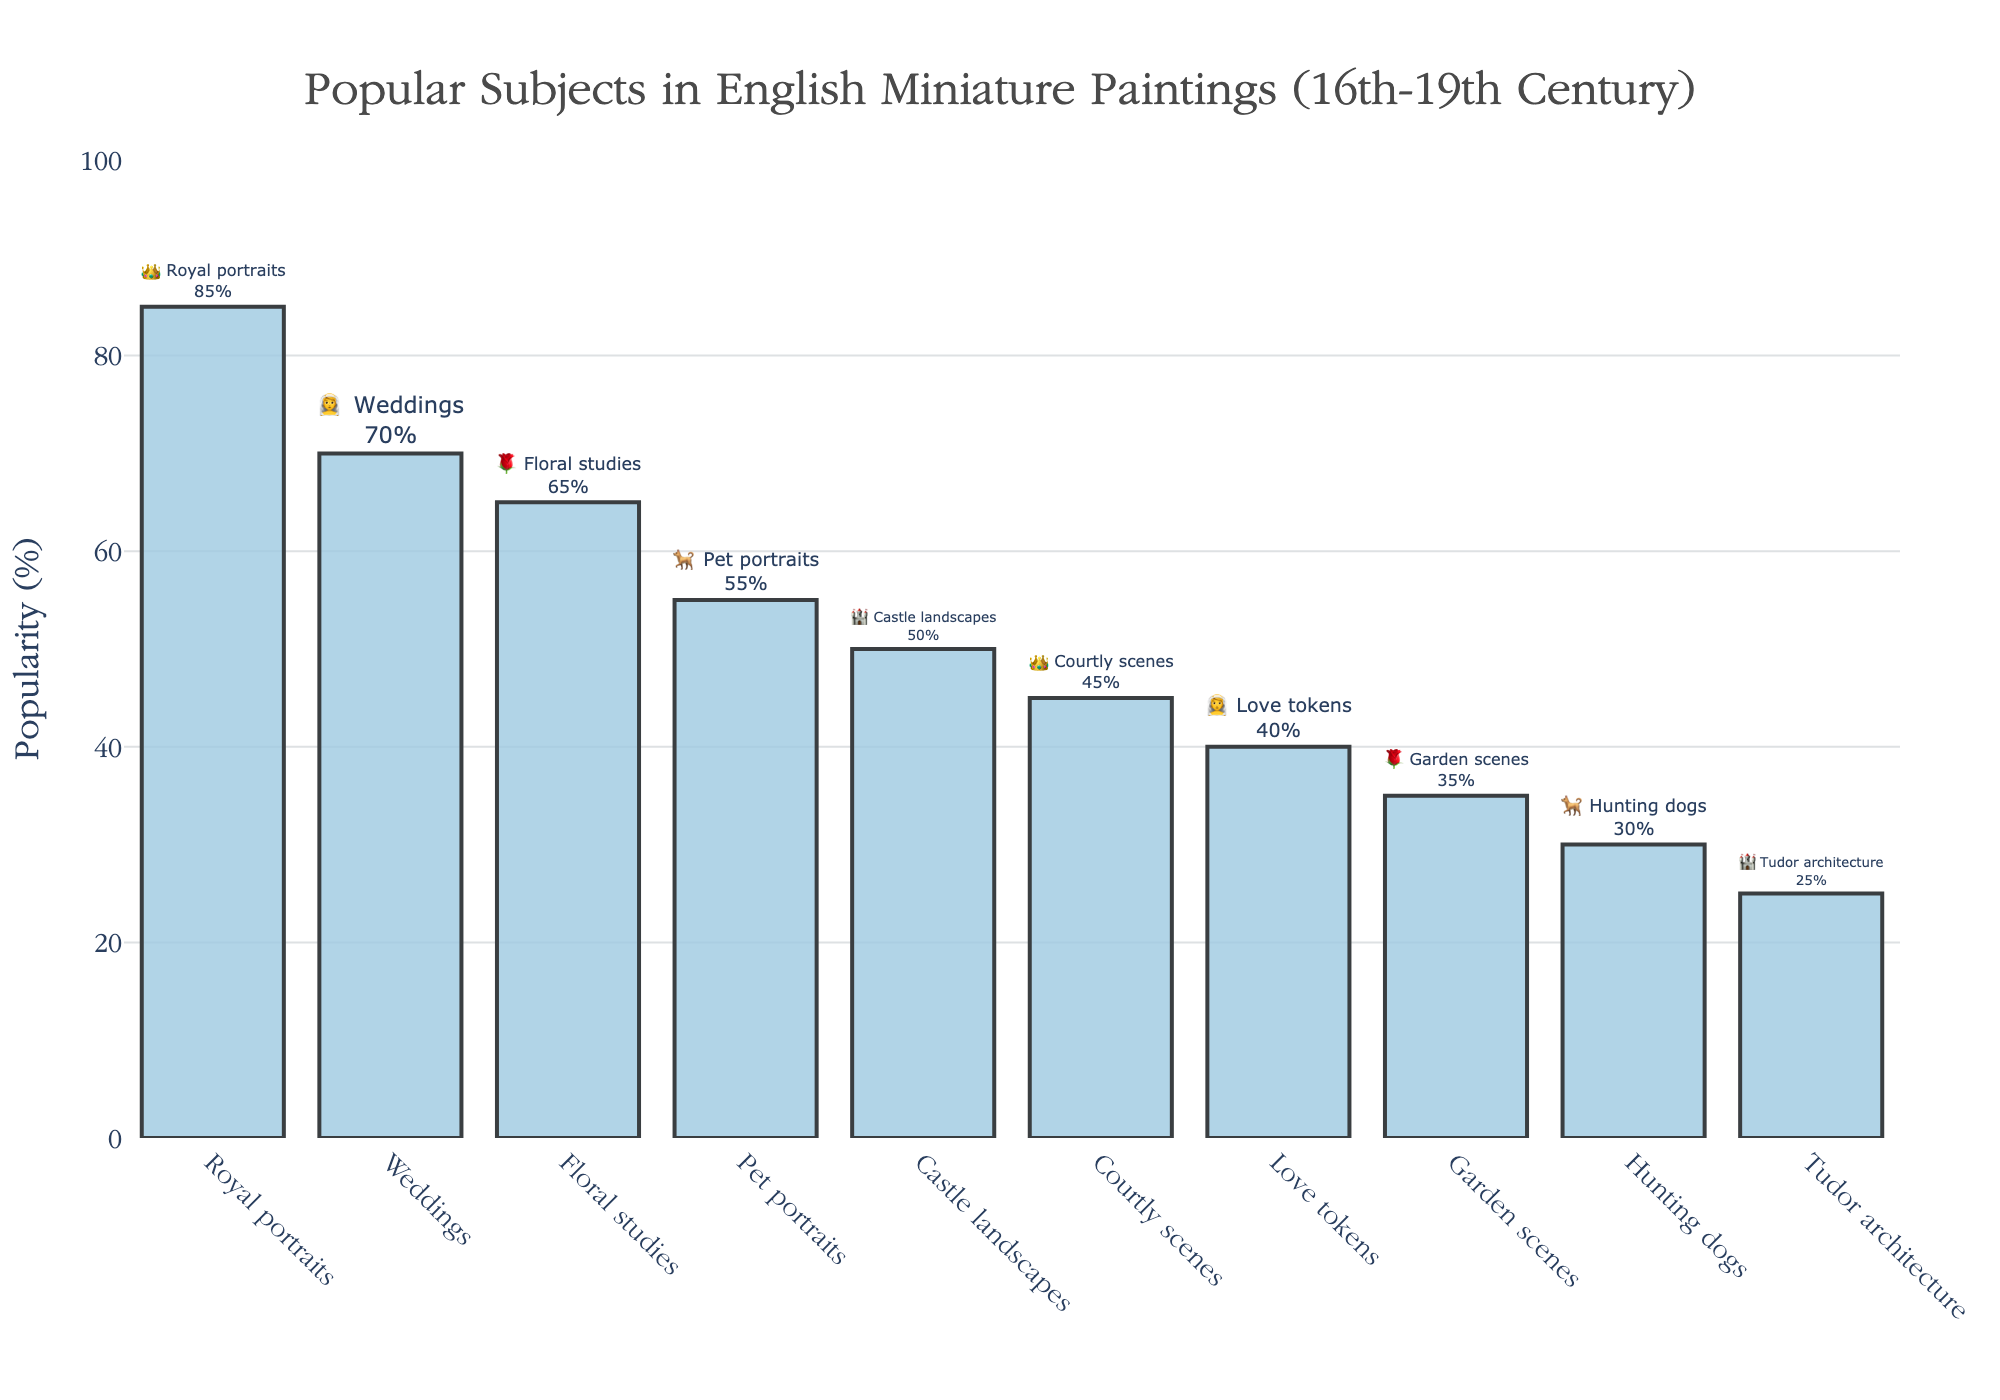What is the title of the figure? The title is usually found at the top of the figure and it provides a quick summary of what the figure represents. In this case, it is "Popular Subjects in English Miniature Paintings (16th-19th Century)"
Answer: Popular Subjects in English Miniature Paintings (16th-19th Century) Which subject has the highest popularity? The bar that reaches the highest point on the Y-axis indicates the most popular subject. Here, the bar labeled "Royal portraits" is the tallest.
Answer: Royal portraits (👑) How much more popular are Royal portraits compared to Tudor architecture? Subtract the popularity percentage of Tudor architecture from that of Royal portraits. Royal portraits have 85% popularity and Tudor architecture has 25%. 85 - 25 = 60
Answer: 60% What are the two least popular subjects, and their popularity percentages? To determine the least popular subjects, look for the bars that are shortest on the Y-axis. These bars are for "Tudor architecture" and "Hunting dogs". Their popularity percentages are 25% and 30% respectively.
Answer: Tudor architecture (25%), Hunting dogs (30%) What is the average popularity percentage of all the subjects? To compute the average, sum all the popularity percentages and divide by the number of subjects. (85 + 70 + 65 + 55 + 50 + 45 + 40 + 35 + 30 + 25) / 10 = 50
Answer: 50% Which emoji represents floral studies and what is its popularity? The figure includes emojis associated with each subject. Find the emoji next to "Floral studies" and its corresponding Y-axis value. The emoji is 🌹 and the popularity is 65%.
Answer: 🌹, 65% Is the popularity of Pet portraits greater or less than that of Weddings? Compare the height of the bars corresponding to Pet portraits and Weddings. Pet portraits have a popularity of 55%, while Weddings have 70%. Therefore, Pet portraits are less popular than Weddings.
Answer: Less How many subjects have a popularity greater than 50%? Count the number of bars that extend above the 50% mark on the Y-axis. Five subjects exceed 50%: "Royal portraits", "Weddings", "Floral studies", "Pet portraits", and "Castle landscapes".
Answer: 5 subjects What is the difference in popularity between Castle landscapes and Courtly scenes? Find the popularity percentage of both subjects and subtract the lower from the higher. Castle landscapes have a popularity of 50%, while Courtly scenes have 45%. 50 - 45 = 5
Answer: 5% What is the median popularity value? To find the median, list the popularity percentages in ascending order and find the middle value. Ordered values: 25, 30, 35, 40, 45, 50, 55, 65, 70, 85. The median is the average of the 5th and 6th values: (45+50)/2 = 47.5
Answer: 47.5% 